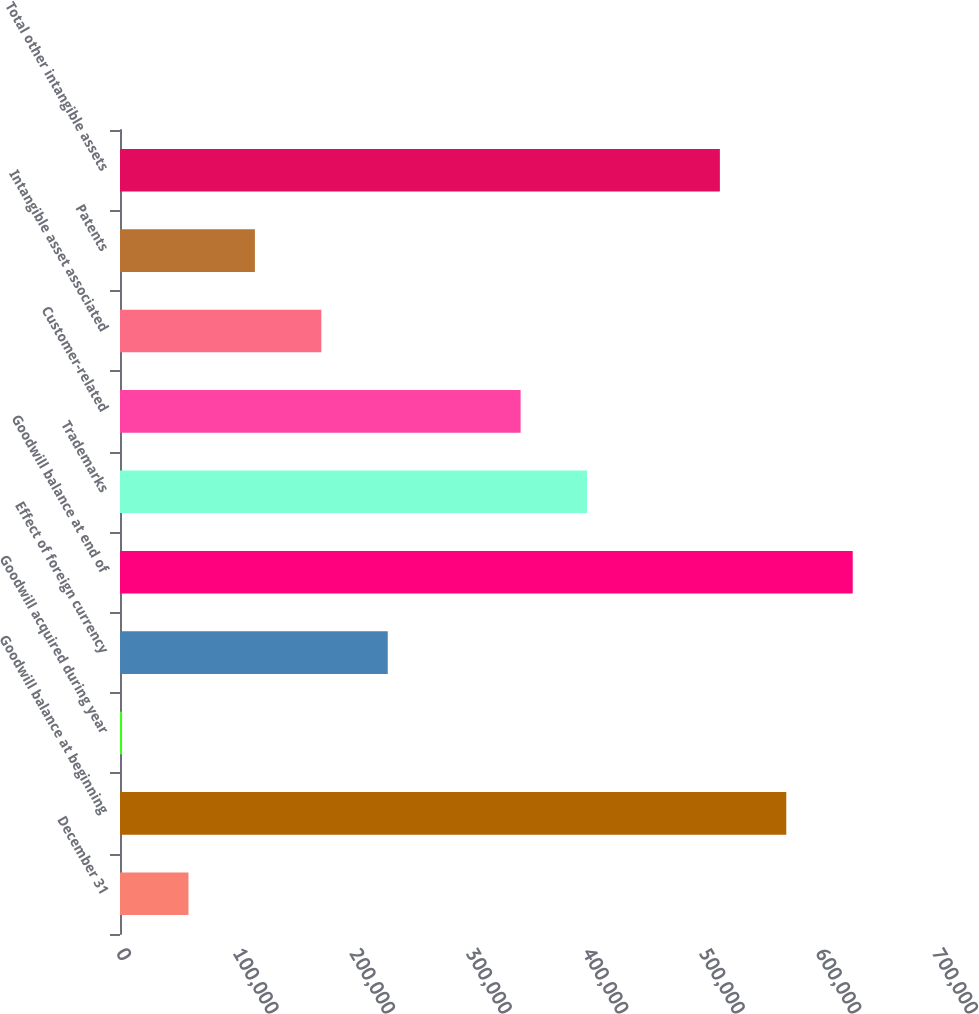<chart> <loc_0><loc_0><loc_500><loc_500><bar_chart><fcel>December 31<fcel>Goodwill balance at beginning<fcel>Goodwill acquired during year<fcel>Effect of foreign currency<fcel>Goodwill balance at end of<fcel>Trademarks<fcel>Customer-related<fcel>Intangible asset associated<fcel>Patents<fcel>Total other intangible assets<nl><fcel>58748.3<fcel>571580<fcel>1767<fcel>229692<fcel>628561<fcel>400636<fcel>343655<fcel>172711<fcel>115730<fcel>514599<nl></chart> 